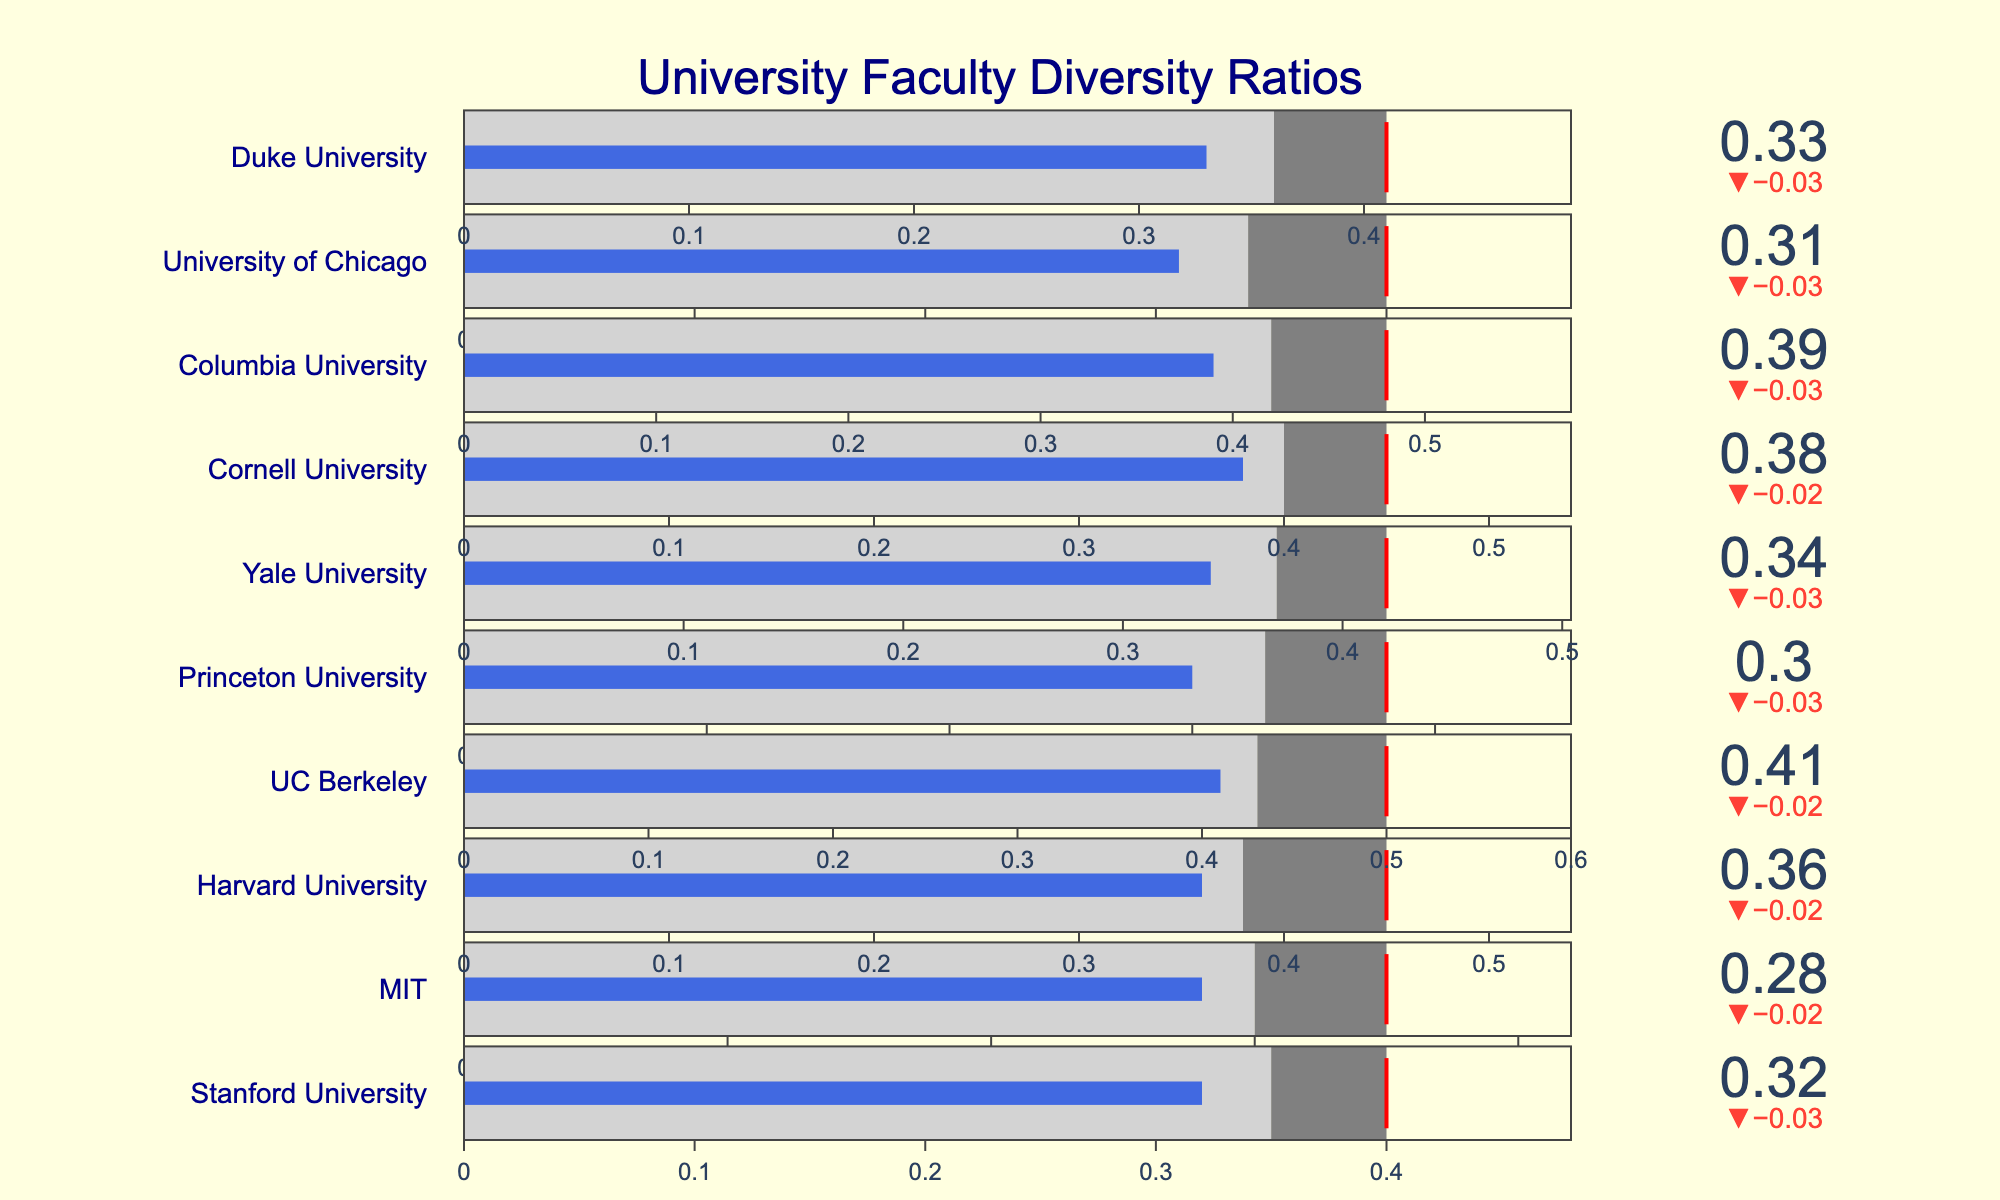Which university has the highest actual diversity ratio? Inspect the actual diversity ratios for each university presented as values on the bullets. UC Berkeley has the highest actual diversity ratio at 0.41.
Answer: UC Berkeley Which universities have an actual diversity ratio above their peer average? Compare the value of the actual diversity ratio with the peer average for each university. If the actual diversity ratio is higher, then these universities are above their peer average. Harvard University, UC Berkeley, Yale University, Cornell University, Columbia University, and Duke University all have actual diversity ratios above their respective peer averages.
Answer: Harvard University, UC Berkeley, Yale University, Cornell University, Columbia University, Duke University What is the target diversity ratio for MIT, and how close is the actual diversity ratio to this target? Look at the target diversity ratio for MIT, then compare it to the actual diversity ratio provided. The target ratio for MIT is 0.35, and the actual ratio is 0.28. The difference is 0.35 - 0.28 = 0.07.
Answer: Target: 0.35, Difference: 0.07 Which university has the smallest difference between its actual diversity ratio and its target ratio? Calculate the difference between the actual diversity ratio and the target ratio for each university and determine which is the smallest. For example, for Stanford, difference = 0.40 - 0.32 = 0.08. Yale University has the smallest difference (0.42 - 0.34 = 0.08).
Answer: Yale University What's the median actual diversity ratio among the listed universities? To find the median, list the actual diversity ratios in ascending order: 0.28, 0.30, 0.31, 0.32, 0.33, 0.34, 0.36, 0.38, 0.39, 0.41. Since there are 10 values, the median is the average of the 5th and 6th values: (0.33 + 0.34) / 2 = 0.335.
Answer: 0.335 Which universities have an actual diversity ratio below 0.30? Identify universities whose actual diversity ratio is less than 0.30. Stanford University and MIT are the only universities with actual diversity ratios below 0.30 (0.32 for Stanford, 0.28 for MIT).
Answer: Stanford University, MIT For how many universities is the actual diversity ratio below their respective target ratio? Compare the actual diversity ratios with their target ratios for each university and count how many are below their targets. All universities' actual diversity ratios are below their target ratios since no actual values exceed their targets.
Answer: 10 Does any university exceed its peer average by more than 0.05 in actual diversity ratio? Calculate the difference between the actual diversity ratio and peer average for each university, and check if any difference is more than 0.05. UC Berkeley exceeds by 0.41 - 0.43 = -0.02. Therefore, no university exceeds by more than 0.05.
Answer: No Which university has the highest peer average diversity ratio, and what is that ratio? Look at the peer average diversity ratio for each university and identify the highest value. UC Berkeley has the highest peer average diversity ratio at 0.43.
Answer: UC Berkeley, 0.43 